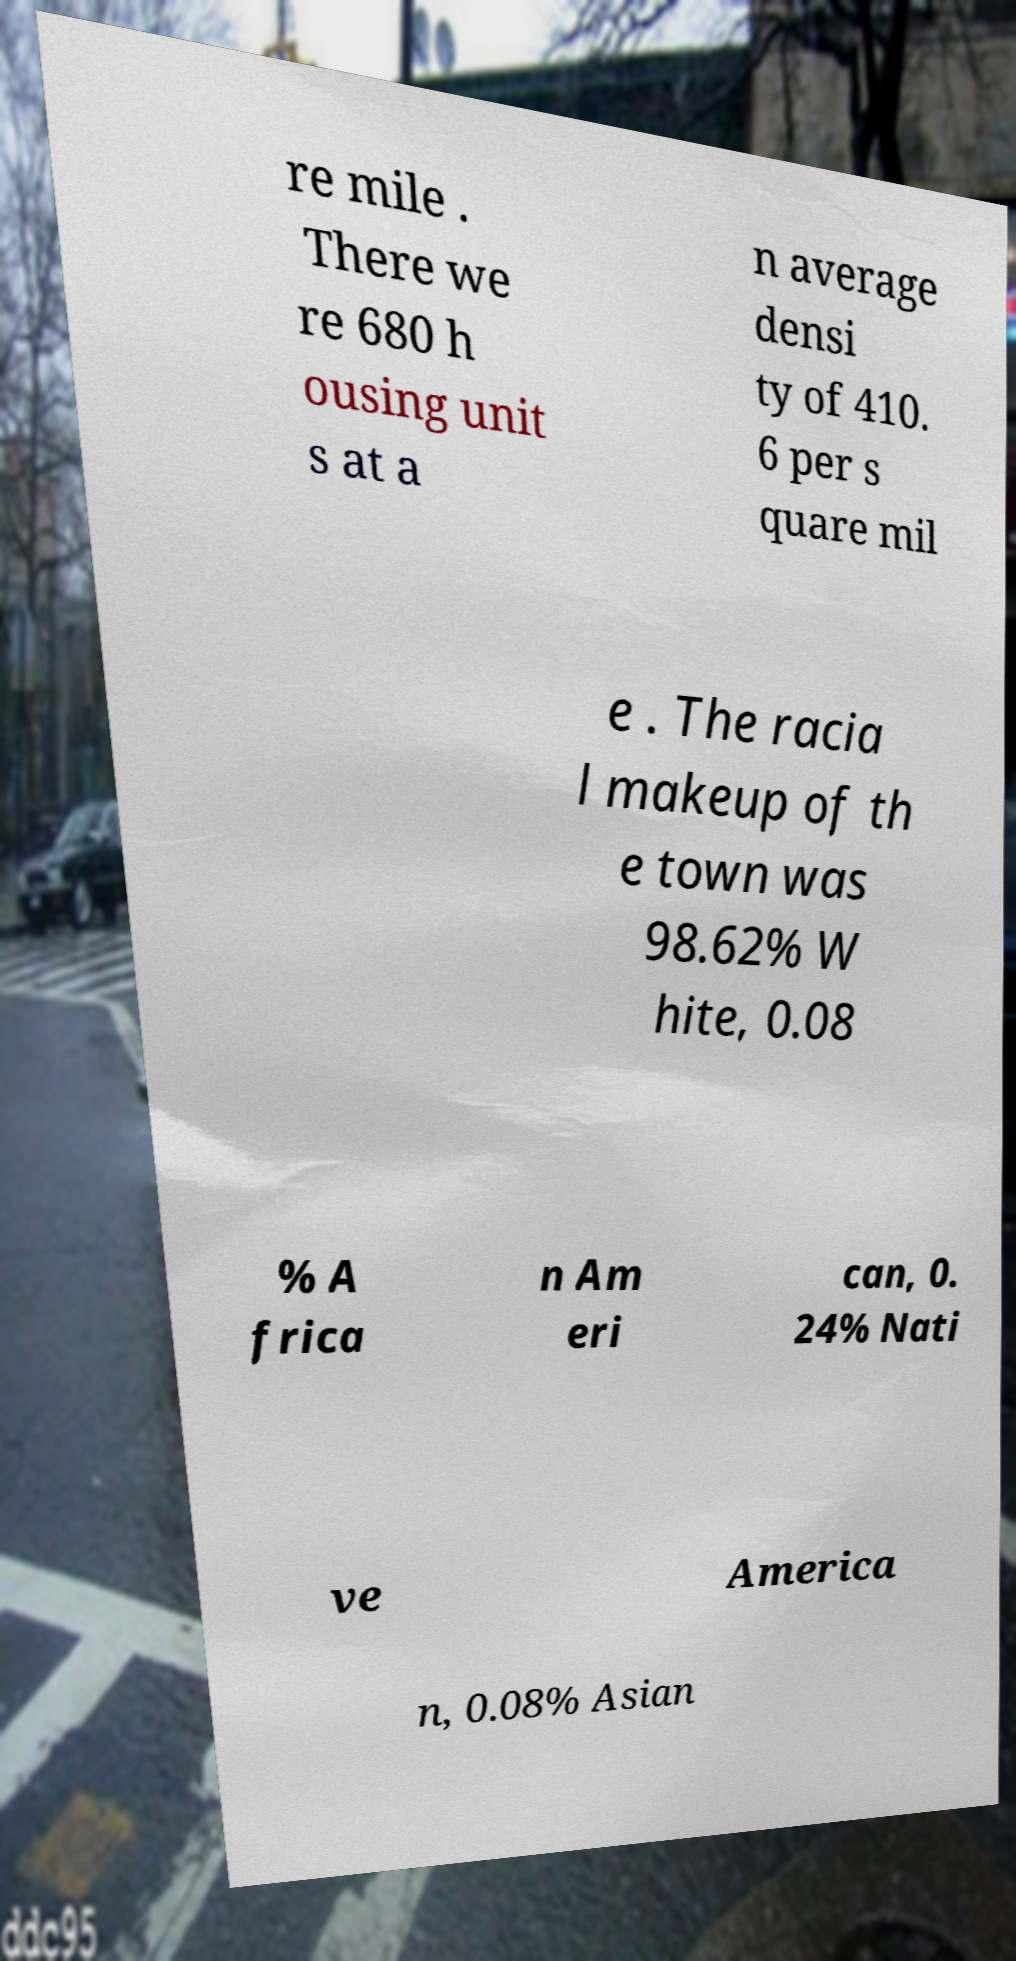What messages or text are displayed in this image? I need them in a readable, typed format. re mile . There we re 680 h ousing unit s at a n average densi ty of 410. 6 per s quare mil e . The racia l makeup of th e town was 98.62% W hite, 0.08 % A frica n Am eri can, 0. 24% Nati ve America n, 0.08% Asian 